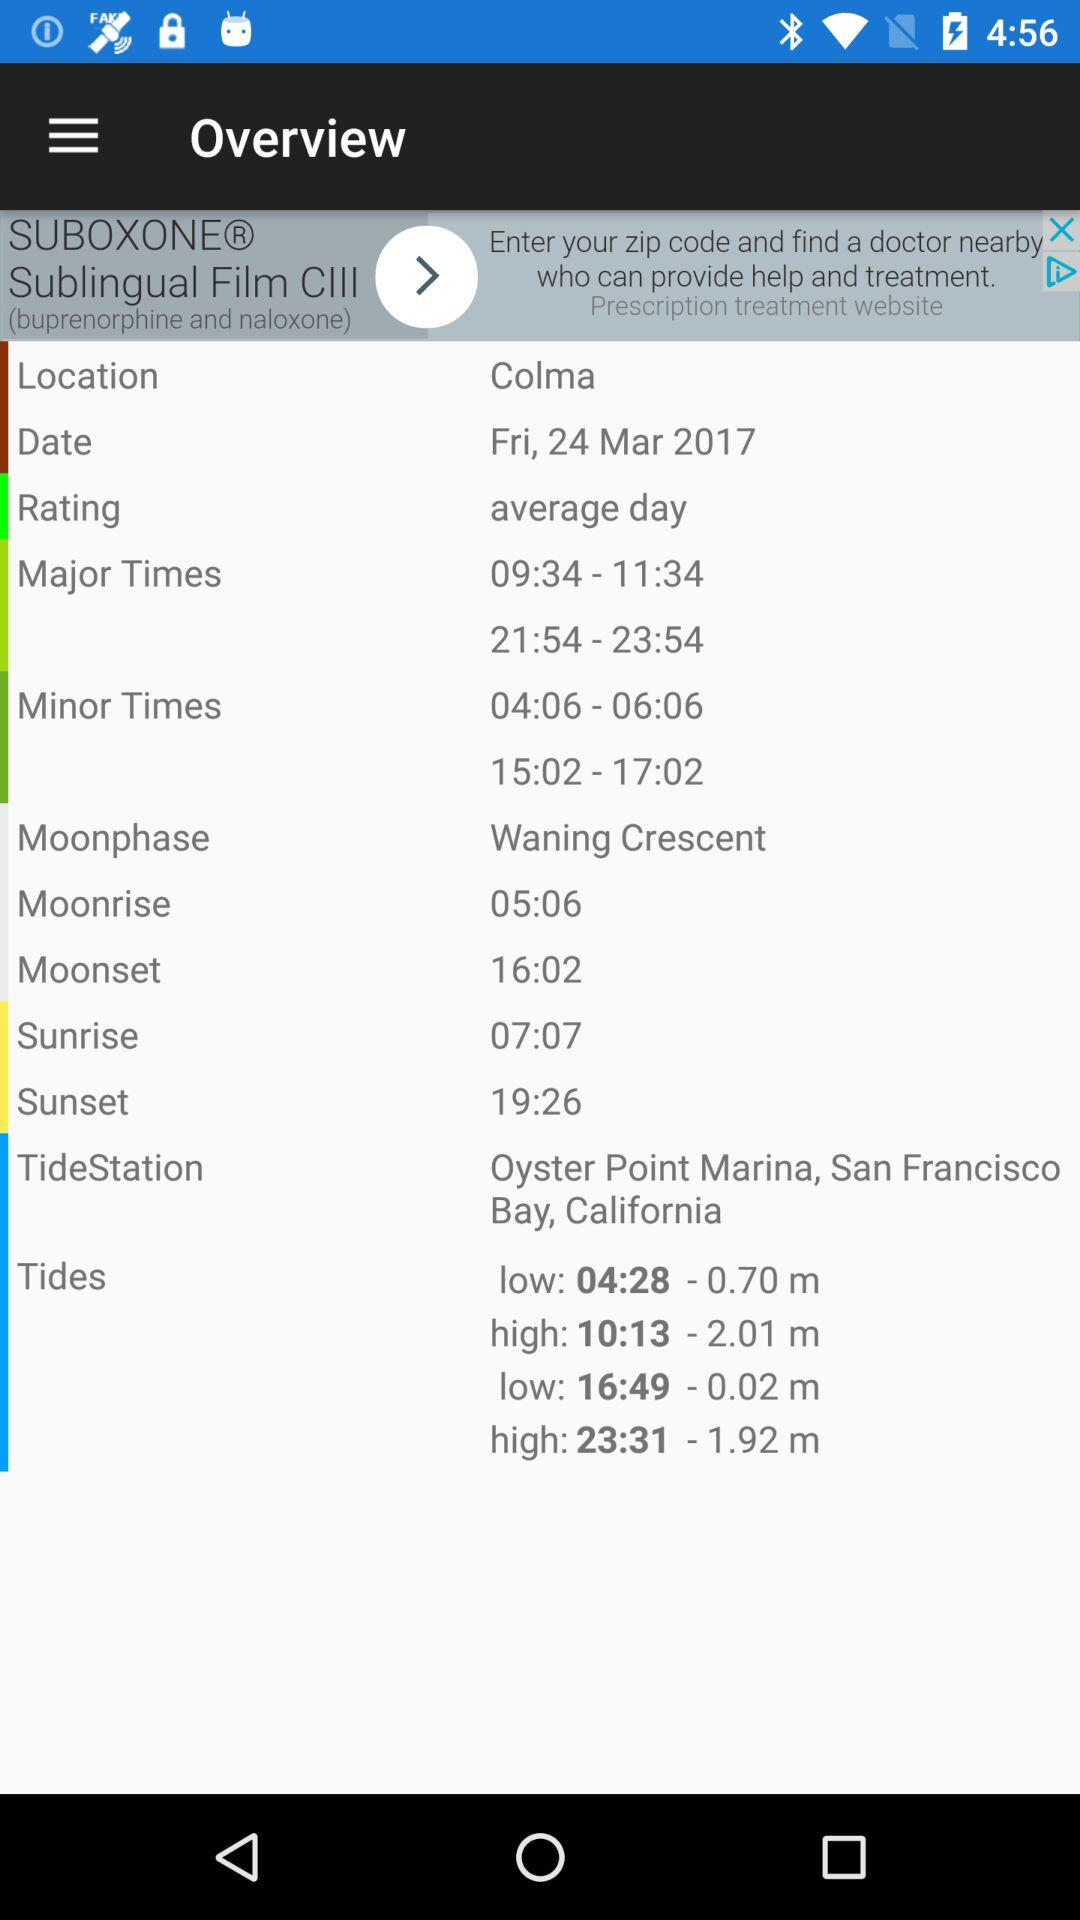What is the location? The locations are Colma and Oyster Point Marina, San Francisco Bay, California. 